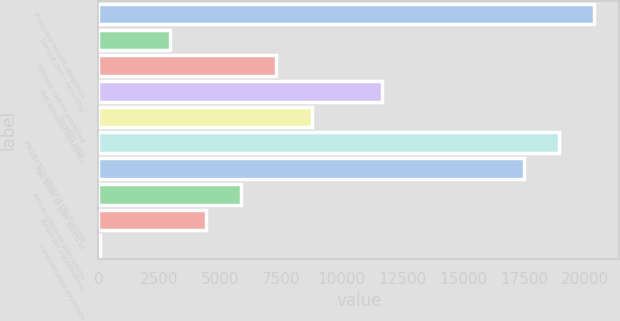<chart> <loc_0><loc_0><loc_500><loc_500><bar_chart><fcel>Projected benefit obligation<fcel>Service cost - excluding<fcel>Interest cost on projected<fcel>Net actuarial loss/(gain)<fcel>Benefits paid<fcel>PROJECTED BENEFIT OBLIGATION<fcel>Fair value of plan assets at<fcel>Actual return on plan assets<fcel>Employer contributions<fcel>Administrative expenses<nl><fcel>20376.2<fcel>2948.6<fcel>7305.5<fcel>11662.4<fcel>8757.8<fcel>18923.9<fcel>17471.6<fcel>5853.2<fcel>4400.9<fcel>44<nl></chart> 